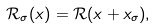Convert formula to latex. <formula><loc_0><loc_0><loc_500><loc_500>\mathcal { R } _ { \sigma } ( x ) = \mathcal { R } ( x + x _ { \sigma } ) ,</formula> 